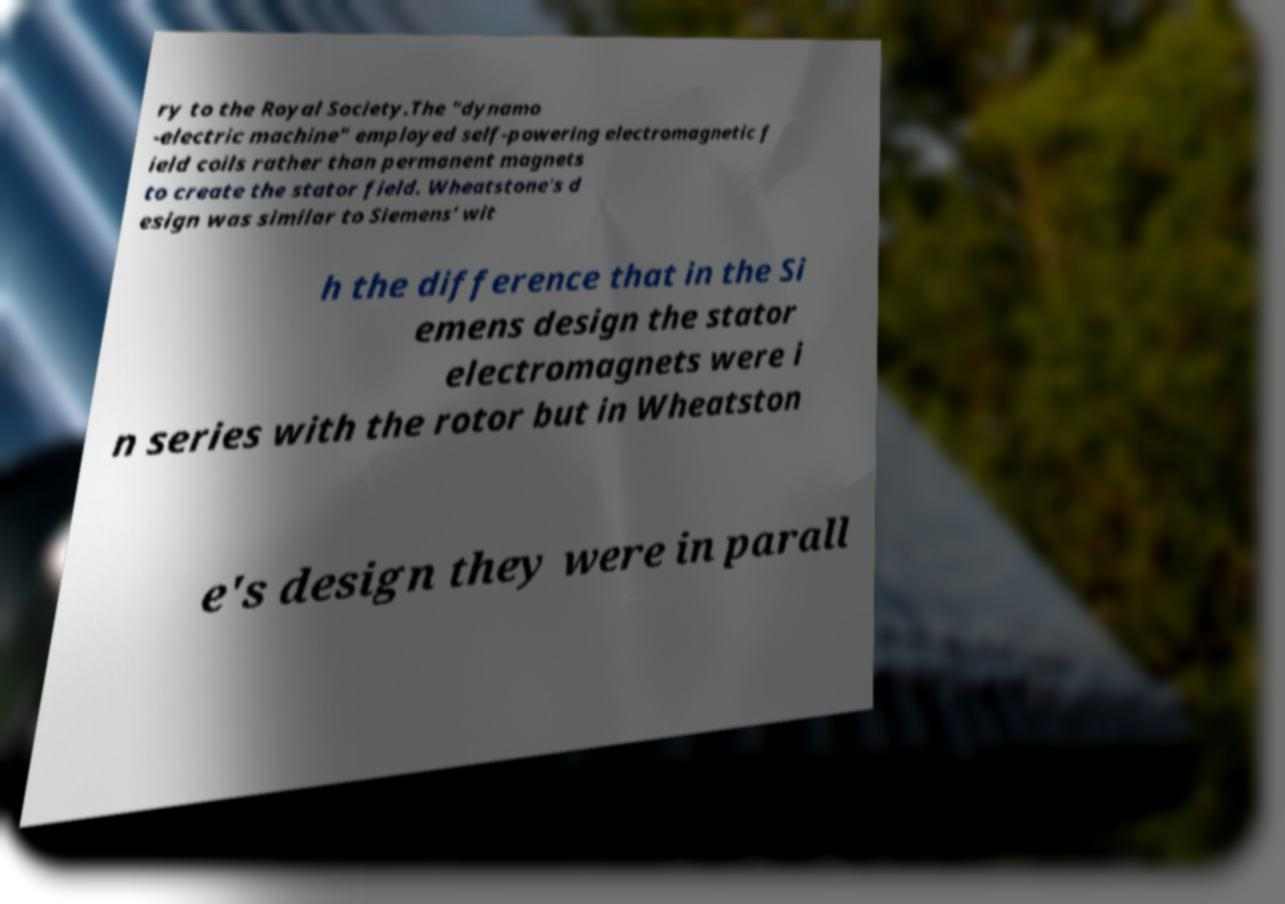Can you accurately transcribe the text from the provided image for me? ry to the Royal Society.The "dynamo -electric machine" employed self-powering electromagnetic f ield coils rather than permanent magnets to create the stator field. Wheatstone's d esign was similar to Siemens' wit h the difference that in the Si emens design the stator electromagnets were i n series with the rotor but in Wheatston e's design they were in parall 